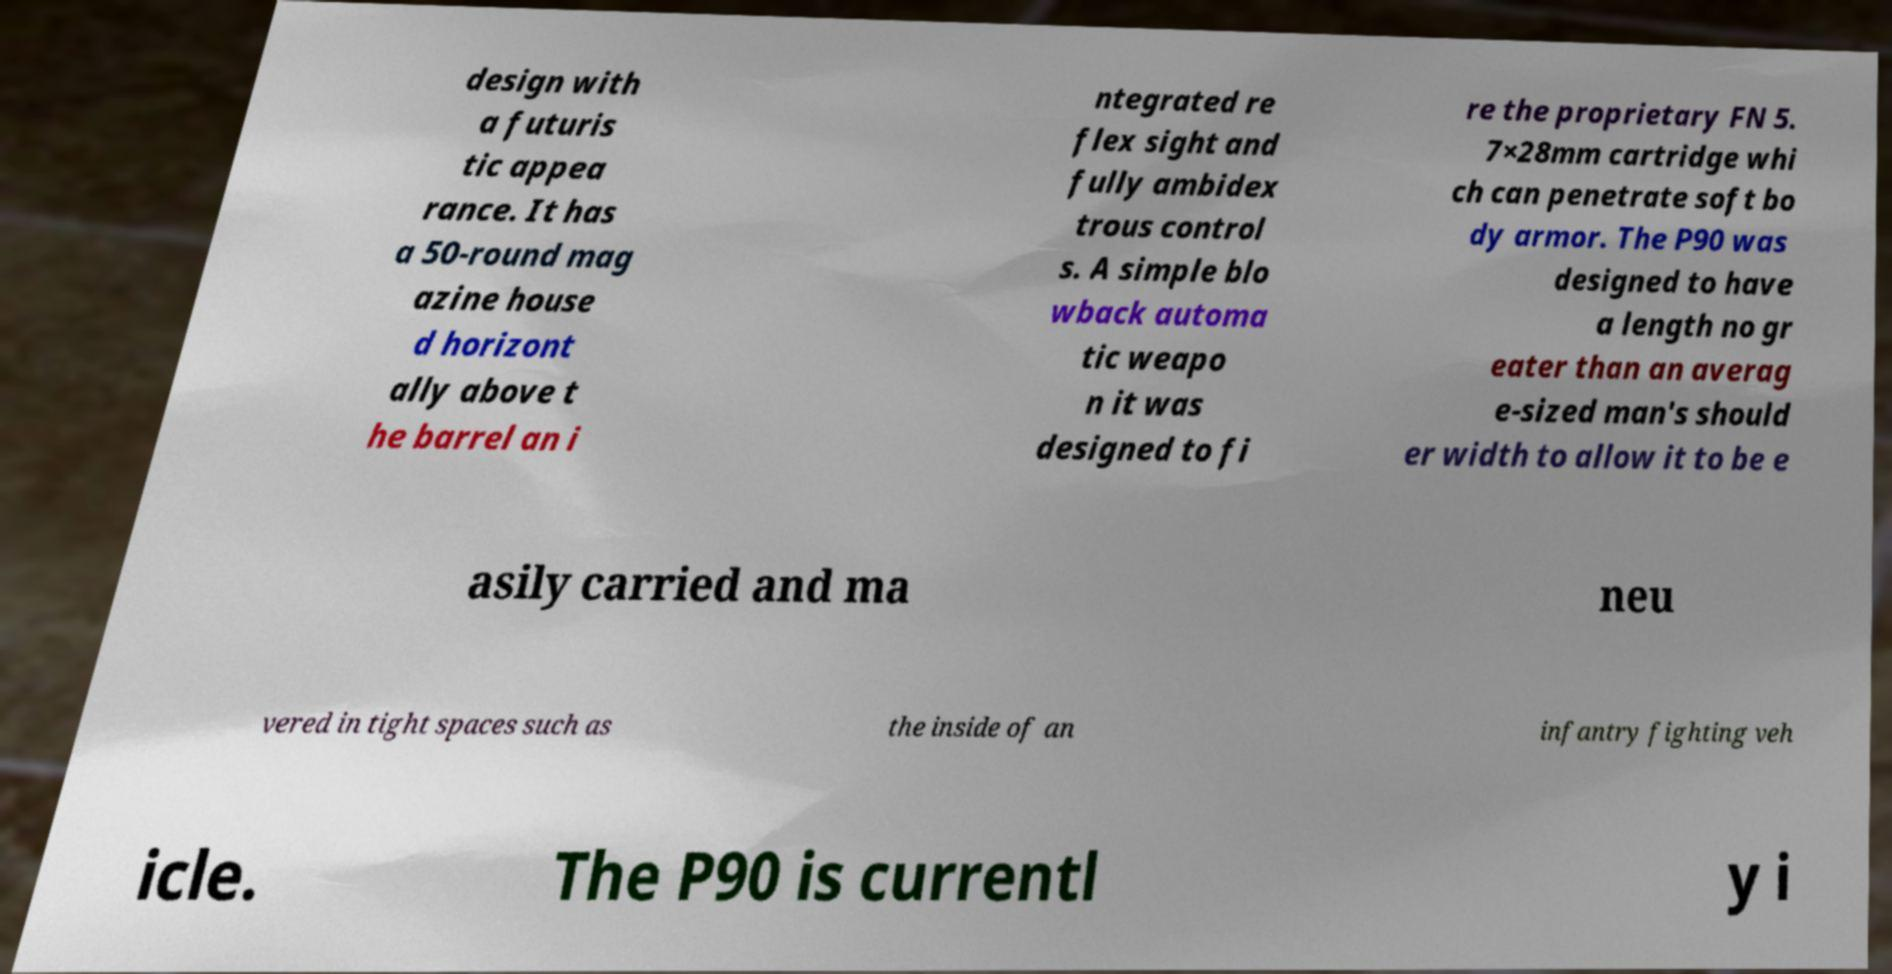There's text embedded in this image that I need extracted. Can you transcribe it verbatim? design with a futuris tic appea rance. It has a 50-round mag azine house d horizont ally above t he barrel an i ntegrated re flex sight and fully ambidex trous control s. A simple blo wback automa tic weapo n it was designed to fi re the proprietary FN 5. 7×28mm cartridge whi ch can penetrate soft bo dy armor. The P90 was designed to have a length no gr eater than an averag e-sized man's should er width to allow it to be e asily carried and ma neu vered in tight spaces such as the inside of an infantry fighting veh icle. The P90 is currentl y i 